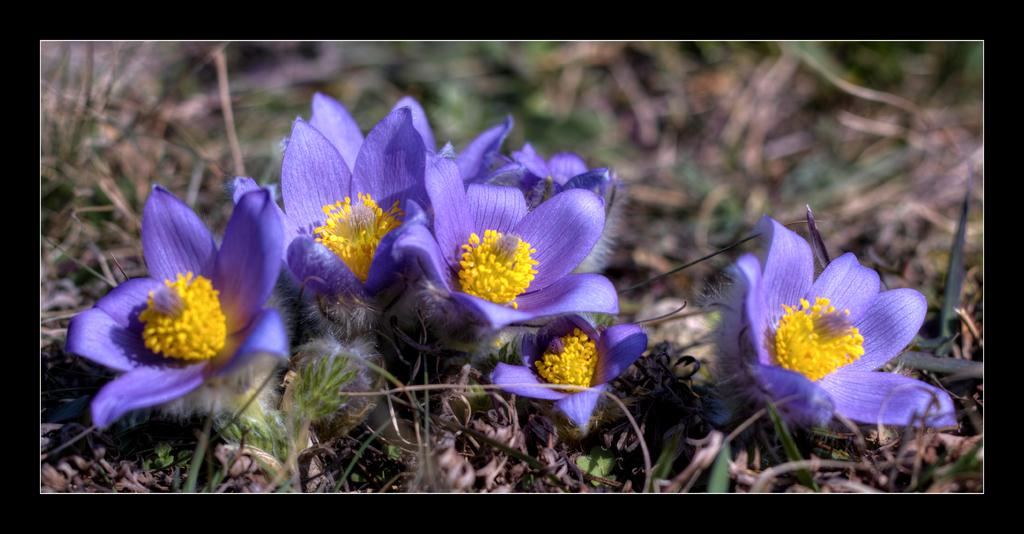What type of plants can be seen in the image? There are flowers in the image. What else can be seen on the ground in the image? There is grass in the image. Are the flowers and grass located on a surface in the image? Yes, both the flowers and grass are on the ground. What type of stone can be seen in the image? There is no stone present in the image; it features flowers and grass on the ground. How many divisions are visible in the image? The image does not depict any divisions or sections; it shows flowers and grass on the ground. 